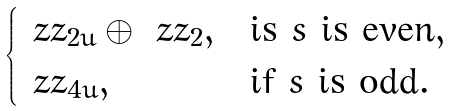<formula> <loc_0><loc_0><loc_500><loc_500>\begin{cases} \ z z _ { 2 u } \oplus \ z z _ { 2 } , & \text {is $s$ is even} , \\ \ z z _ { 4 u } , & \text {if $s$ is odd} . \end{cases}</formula> 